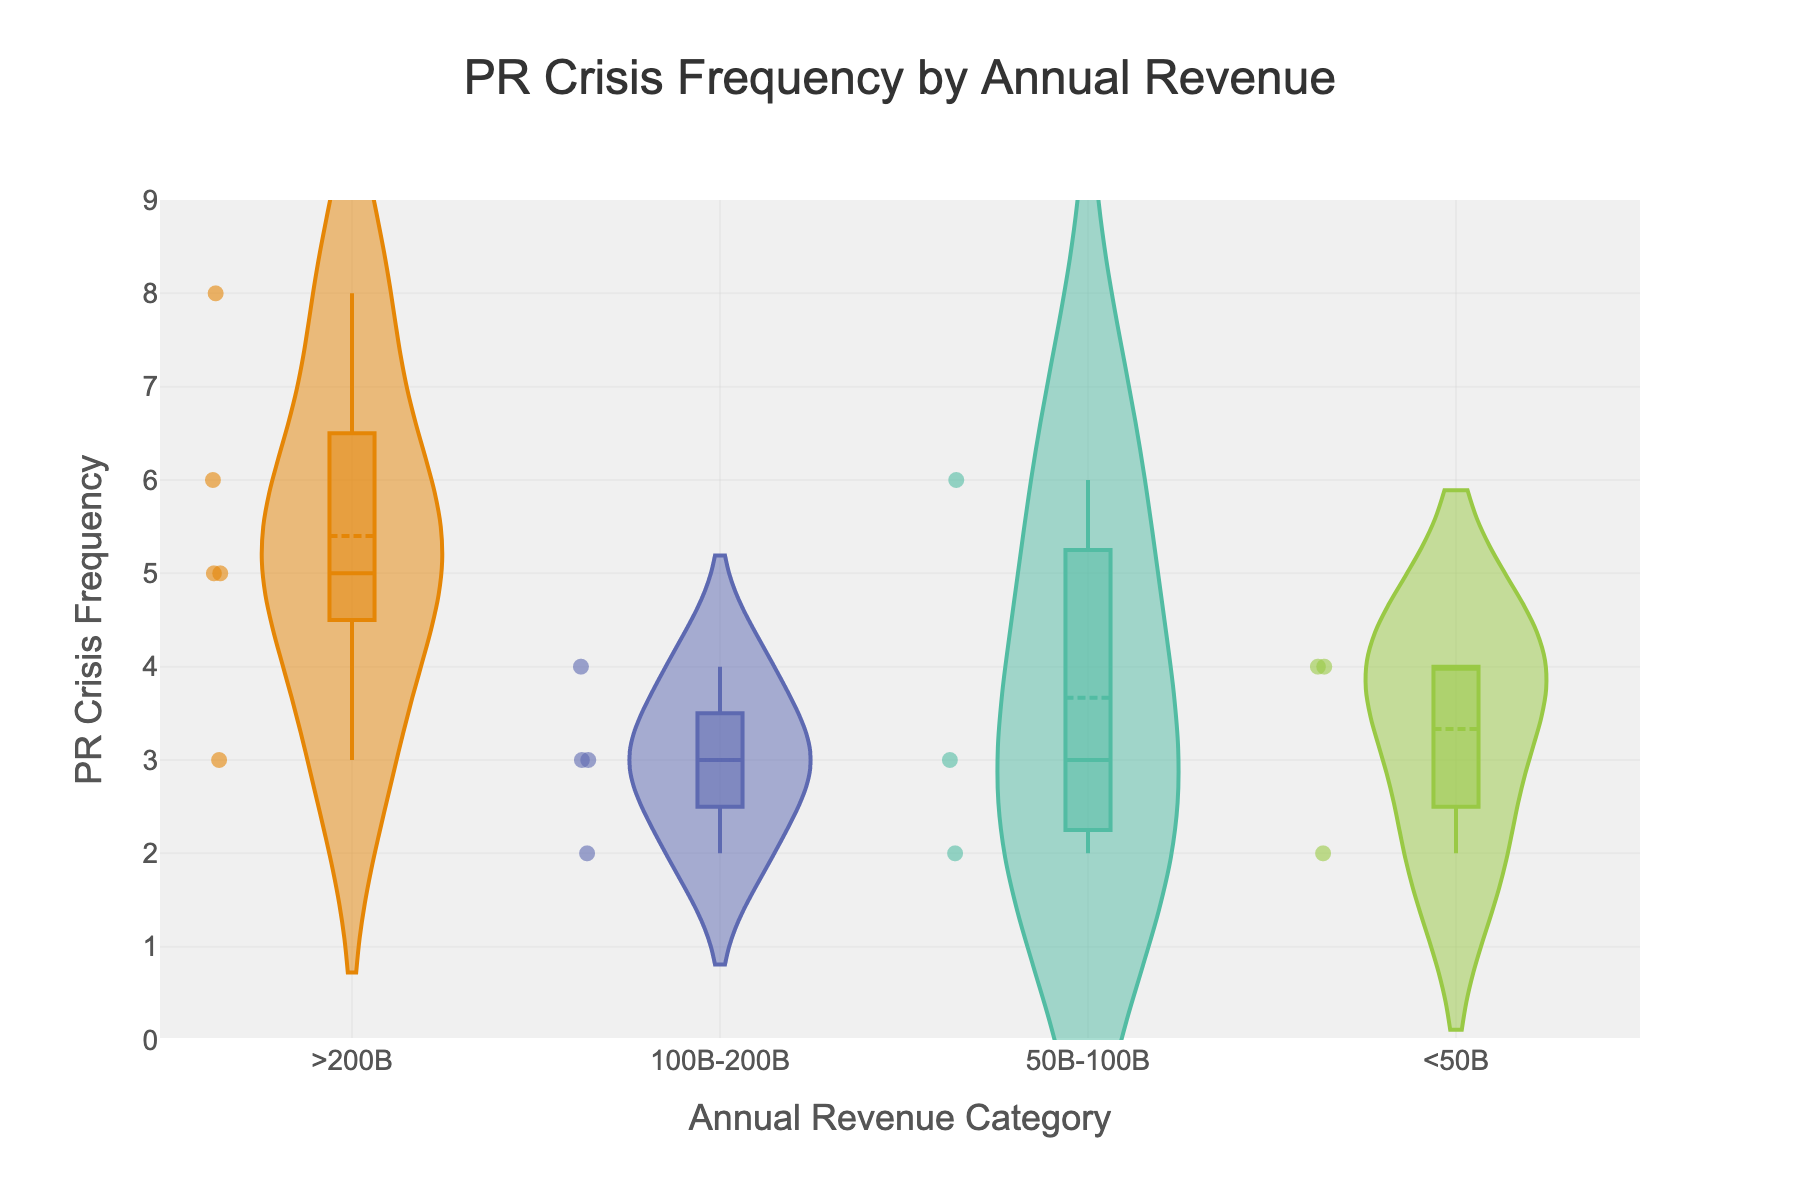What is the title of the figure? The title is prominently displayed at the top of the figure, usually in a larger and bold font.
Answer: PR Crisis Frequency by Annual Revenue What is the range of the y-axis? The y-axis typically indicates the numeric range, with tick marks showing minimum and maximum values. Based on the description, the y-axis should cover 0 to one unit above the maximum data point in the dataset. The highest frequency value is 8, so the range should be from 0 to 9.
Answer: 0 to 9 What's the category with the most PR crises? By looking at the density of points and the extent of the violin in each category, the category with the highest frequency of PR crises will be more pronounced.
Answer: >200B Which revenue category has the widest spread in PR crisis frequency? Observing the violin's width across different revenue categories, the widest spread indicates the highest variability in PR crisis frequency within that category.
Answer: >200B How many data points are there for the category '100B-200B'? Each data point corresponds to a PR crisis frequency for each company in that particular revenue category. By counting the visible points within the ‘100B-200B’ category’s violin plot, we can determine this number.
Answer: 4 Compare the mean PR crisis frequency between '<50B' and '50B-100B' revenue categories. The mean PR crisis frequency is often denoted by a solid line in each violin plot. Observing the position of these lines helps compare means across categories.
Answer: The '50B-100B' category has a higher mean than the '<50B' category What can you tell about the median PR crisis frequency for the '>200B' revenue category? The median is represented by the central line of a box in the violin plots. Drawing observations from the position of this line provides insights.
Answer: The median seems to be around 5 Which revenue category has the smallest number of PR crises? By looking at the violin plot with the smallest spread and the minimum value for PR crises, we can identify the category.
Answer: 100B-200B Describe the overall trend in PR crisis frequency as companies' revenue increases. Analyzing the shape and spread of the violins across increasing revenue categories helps observe any general patterns or trends.
Answer: PR crisis frequency generally increases with higher revenue levels 